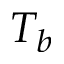Convert formula to latex. <formula><loc_0><loc_0><loc_500><loc_500>T _ { b }</formula> 